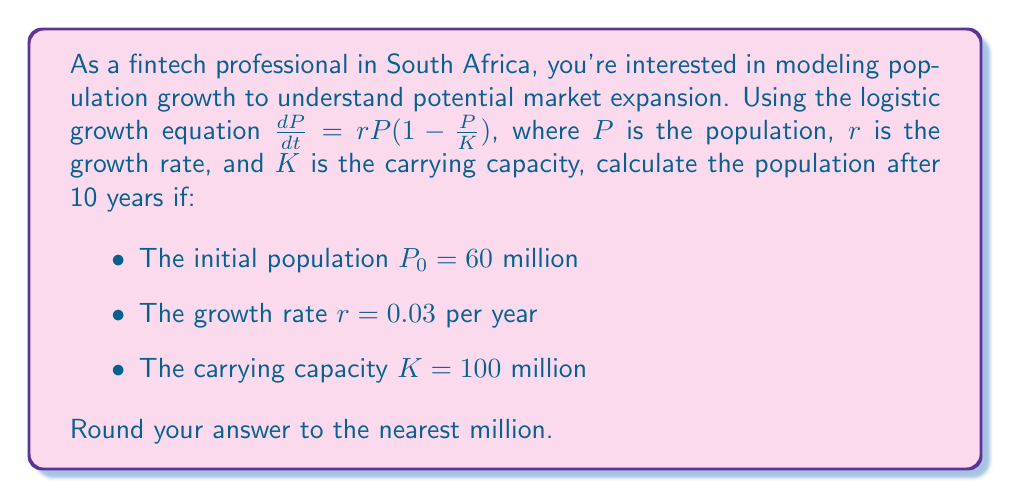Show me your answer to this math problem. To solve this problem, we'll use the solution to the logistic growth equation:

$$P(t) = \frac{KP_0}{P_0 + (K-P_0)e^{-rt}}$$

Where:
$P(t)$ is the population at time $t$
$P_0$ is the initial population
$K$ is the carrying capacity
$r$ is the growth rate
$t$ is the time in years

Let's substitute the given values:
$P_0 = 60$ million
$K = 100$ million
$r = 0.03$ per year
$t = 10$ years

Now, let's calculate step by step:

1) First, calculate $(K-P_0)$:
   $100 - 60 = 40$ million

2) Calculate $e^{-rt}$:
   $e^{-0.03 \times 10} = e^{-0.3} \approx 0.7408$

3) Multiply $(K-P_0)$ by $e^{-rt}$:
   $40 \times 0.7408 = 29.632$ million

4) Add $P_0$ to the result from step 3:
   $60 + 29.632 = 89.632$ million

5) Multiply $K$ and $P_0$:
   $100 \times 60 = 6000$ million

6) Divide the result from step 5 by the result from step 4:
   $\frac{6000}{89.632} \approx 66.94$ million

7) Round to the nearest million:
   $66.94$ million rounds to $67$ million
Answer: 67 million 